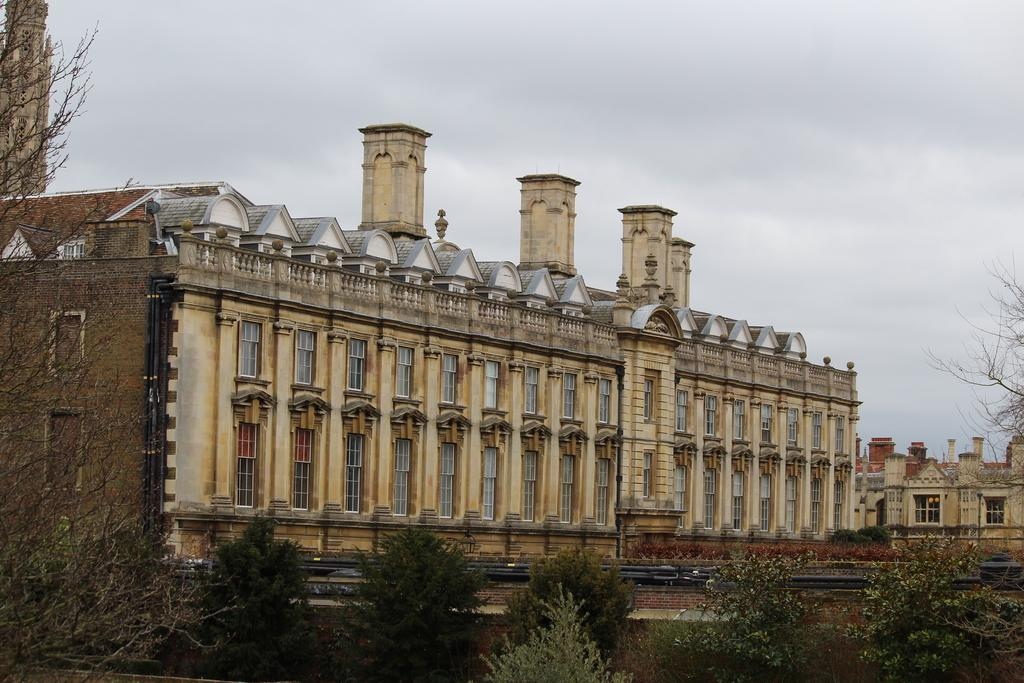What is the main subject of the picture? The main subject of the picture is a building. What specific features can be observed on the building? The building has windows. Are there any other buildings visible in the picture? Yes, there is another building on the right side of the picture. What type of vegetation is present in the picture? There are trees in the picture. How would you describe the weather based on the image? The sky is cloudy in the picture. What type of underwear is hanging on the clothesline in the picture? There is no clothesline or underwear present in the image; it features a building with windows and trees. What type of polish is being applied to the judge's shoes in the picture? There is no judge or shoes present in the image, and therefore no polish application can be observed. 